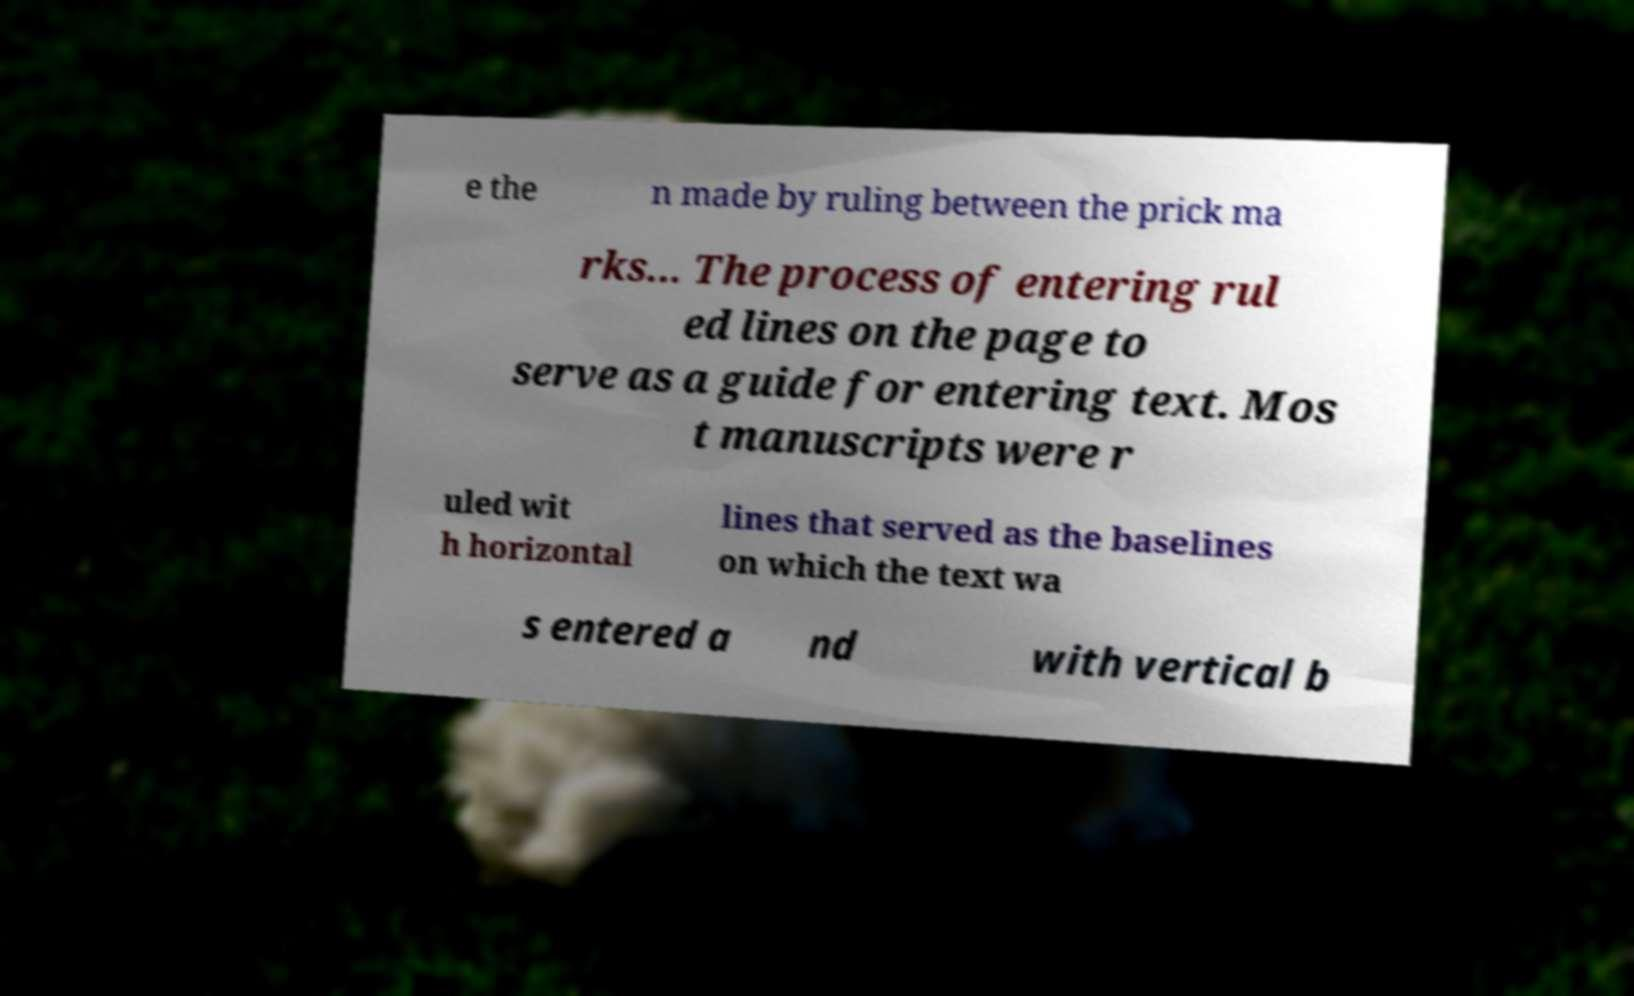Can you read and provide the text displayed in the image?This photo seems to have some interesting text. Can you extract and type it out for me? e the n made by ruling between the prick ma rks... The process of entering rul ed lines on the page to serve as a guide for entering text. Mos t manuscripts were r uled wit h horizontal lines that served as the baselines on which the text wa s entered a nd with vertical b 